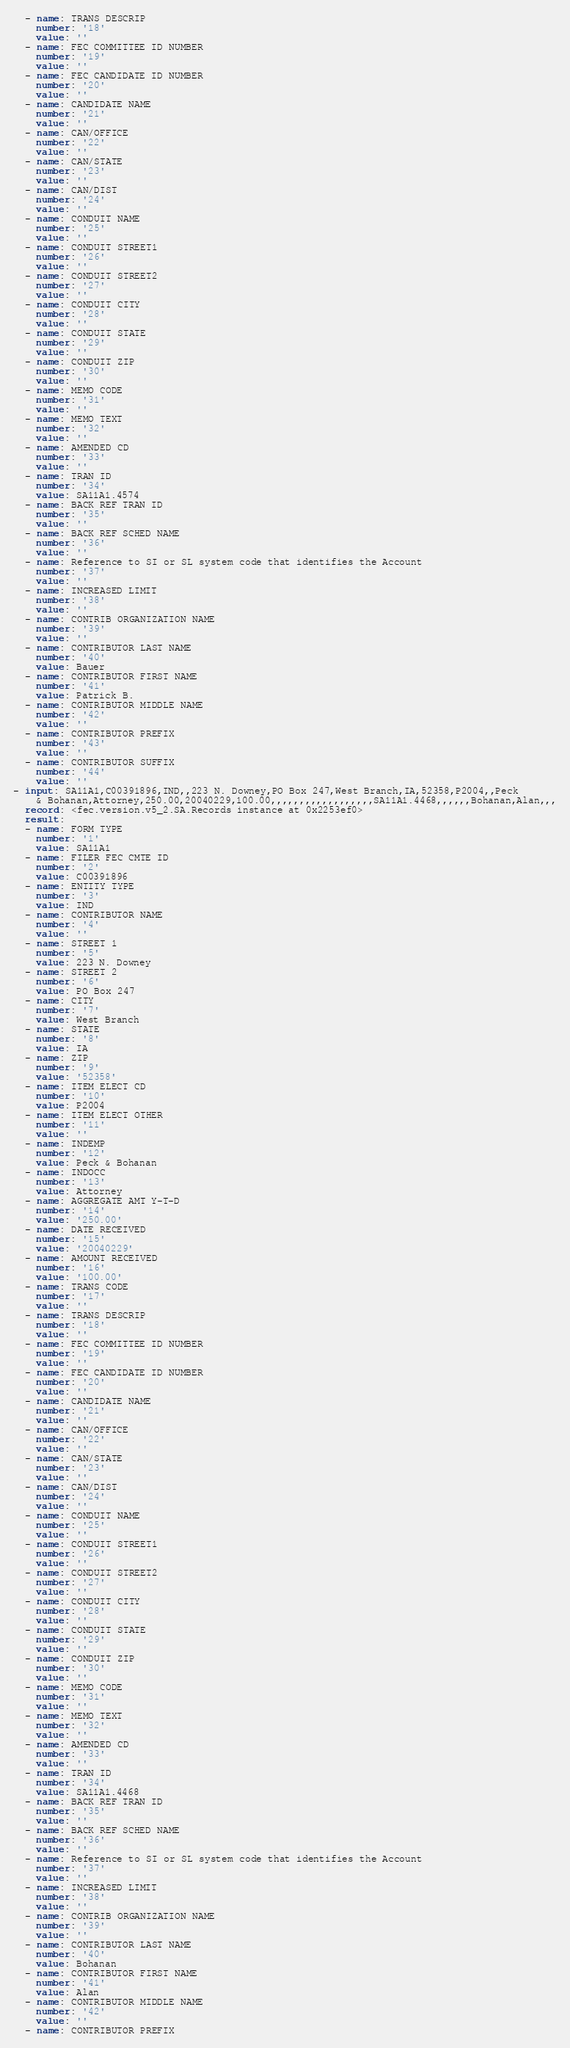<code> <loc_0><loc_0><loc_500><loc_500><_YAML_>  - name: TRANS DESCRIP
    number: '18'
    value: ''
  - name: FEC COMMITTEE ID NUMBER
    number: '19'
    value: ''
  - name: FEC CANDIDATE ID NUMBER
    number: '20'
    value: ''
  - name: CANDIDATE NAME
    number: '21'
    value: ''
  - name: CAN/OFFICE
    number: '22'
    value: ''
  - name: CAN/STATE
    number: '23'
    value: ''
  - name: CAN/DIST
    number: '24'
    value: ''
  - name: CONDUIT NAME
    number: '25'
    value: ''
  - name: CONDUIT STREET1
    number: '26'
    value: ''
  - name: CONDUIT STREET2
    number: '27'
    value: ''
  - name: CONDUIT CITY
    number: '28'
    value: ''
  - name: CONDUIT STATE
    number: '29'
    value: ''
  - name: CONDUIT ZIP
    number: '30'
    value: ''
  - name: MEMO CODE
    number: '31'
    value: ''
  - name: MEMO TEXT
    number: '32'
    value: ''
  - name: AMENDED CD
    number: '33'
    value: ''
  - name: TRAN ID
    number: '34'
    value: SA11A1.4574
  - name: BACK REF TRAN ID
    number: '35'
    value: ''
  - name: BACK REF SCHED NAME
    number: '36'
    value: ''
  - name: Reference to SI or SL system code that identifies the Account
    number: '37'
    value: ''
  - name: INCREASED LIMIT
    number: '38'
    value: ''
  - name: CONTRIB ORGANIZATION NAME
    number: '39'
    value: ''
  - name: CONTRIBUTOR LAST NAME
    number: '40'
    value: Bauer
  - name: CONTRIBUTOR FIRST NAME
    number: '41'
    value: Patrick B.
  - name: CONTRIBUTOR MIDDLE NAME
    number: '42'
    value: ''
  - name: CONTRIBUTOR PREFIX
    number: '43'
    value: ''
  - name: CONTRIBUTOR SUFFIX
    number: '44'
    value: ''
- input: SA11A1,C00391896,IND,,223 N. Downey,PO Box 247,West Branch,IA,52358,P2004,,Peck
    & Bohanan,Attorney,250.00,20040229,100.00,,,,,,,,,,,,,,,,,,SA11A1.4468,,,,,,Bohanan,Alan,,,
  record: <fec.version.v5_2.SA.Records instance at 0x2253ef0>
  result:
  - name: FORM TYPE
    number: '1'
    value: SA11A1
  - name: FILER FEC CMTE ID
    number: '2'
    value: C00391896
  - name: ENTITY TYPE
    number: '3'
    value: IND
  - name: CONTRIBUTOR NAME
    number: '4'
    value: ''
  - name: STREET 1
    number: '5'
    value: 223 N. Downey
  - name: STREET 2
    number: '6'
    value: PO Box 247
  - name: CITY
    number: '7'
    value: West Branch
  - name: STATE
    number: '8'
    value: IA
  - name: ZIP
    number: '9'
    value: '52358'
  - name: ITEM ELECT CD
    number: '10'
    value: P2004
  - name: ITEM ELECT OTHER
    number: '11'
    value: ''
  - name: INDEMP
    number: '12'
    value: Peck & Bohanan
  - name: INDOCC
    number: '13'
    value: Attorney
  - name: AGGREGATE AMT Y-T-D
    number: '14'
    value: '250.00'
  - name: DATE RECEIVED
    number: '15'
    value: '20040229'
  - name: AMOUNT RECEIVED
    number: '16'
    value: '100.00'
  - name: TRANS CODE
    number: '17'
    value: ''
  - name: TRANS DESCRIP
    number: '18'
    value: ''
  - name: FEC COMMITTEE ID NUMBER
    number: '19'
    value: ''
  - name: FEC CANDIDATE ID NUMBER
    number: '20'
    value: ''
  - name: CANDIDATE NAME
    number: '21'
    value: ''
  - name: CAN/OFFICE
    number: '22'
    value: ''
  - name: CAN/STATE
    number: '23'
    value: ''
  - name: CAN/DIST
    number: '24'
    value: ''
  - name: CONDUIT NAME
    number: '25'
    value: ''
  - name: CONDUIT STREET1
    number: '26'
    value: ''
  - name: CONDUIT STREET2
    number: '27'
    value: ''
  - name: CONDUIT CITY
    number: '28'
    value: ''
  - name: CONDUIT STATE
    number: '29'
    value: ''
  - name: CONDUIT ZIP
    number: '30'
    value: ''
  - name: MEMO CODE
    number: '31'
    value: ''
  - name: MEMO TEXT
    number: '32'
    value: ''
  - name: AMENDED CD
    number: '33'
    value: ''
  - name: TRAN ID
    number: '34'
    value: SA11A1.4468
  - name: BACK REF TRAN ID
    number: '35'
    value: ''
  - name: BACK REF SCHED NAME
    number: '36'
    value: ''
  - name: Reference to SI or SL system code that identifies the Account
    number: '37'
    value: ''
  - name: INCREASED LIMIT
    number: '38'
    value: ''
  - name: CONTRIB ORGANIZATION NAME
    number: '39'
    value: ''
  - name: CONTRIBUTOR LAST NAME
    number: '40'
    value: Bohanan
  - name: CONTRIBUTOR FIRST NAME
    number: '41'
    value: Alan
  - name: CONTRIBUTOR MIDDLE NAME
    number: '42'
    value: ''
  - name: CONTRIBUTOR PREFIX</code> 